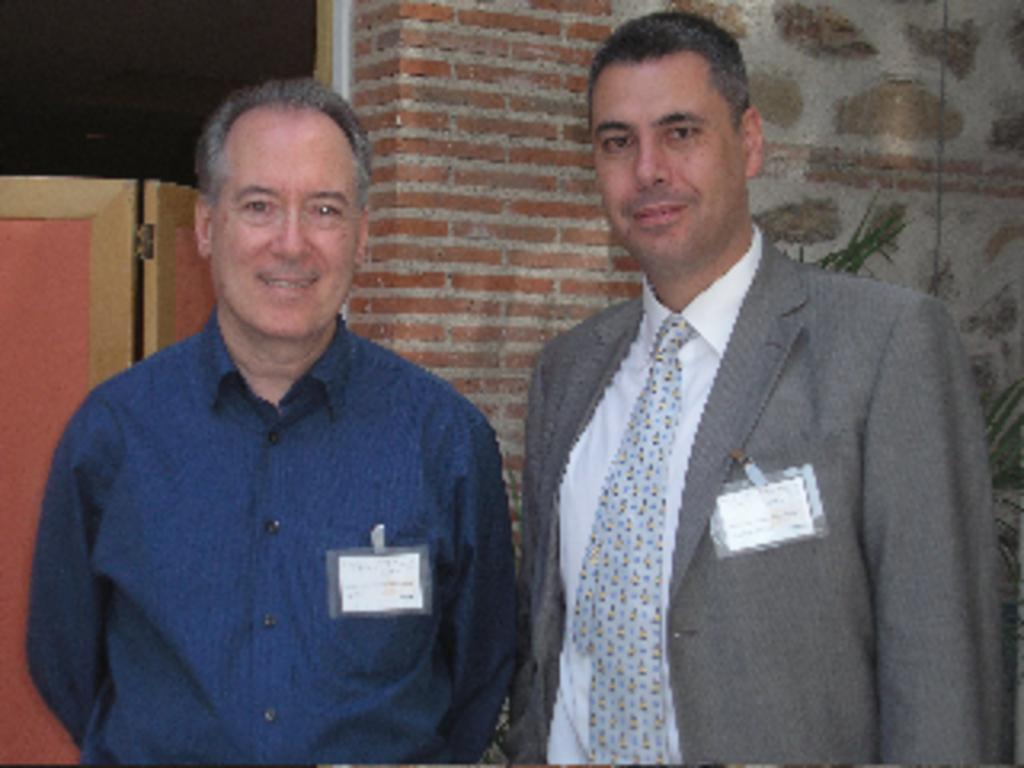What can be seen in the image regarding the people present? There are men standing in the image. What are the men holding in the image? The men have ID cards. Can you describe the attire of one of the men? One man is wearing a coat and a tie. What can be seen in the background of the image? There is a door and a wall visible in the background of the image. What type of beef is being served on the woolen tablecloth in the image? There is no beef or woolen tablecloth present in the image; it features men standing with ID cards. 